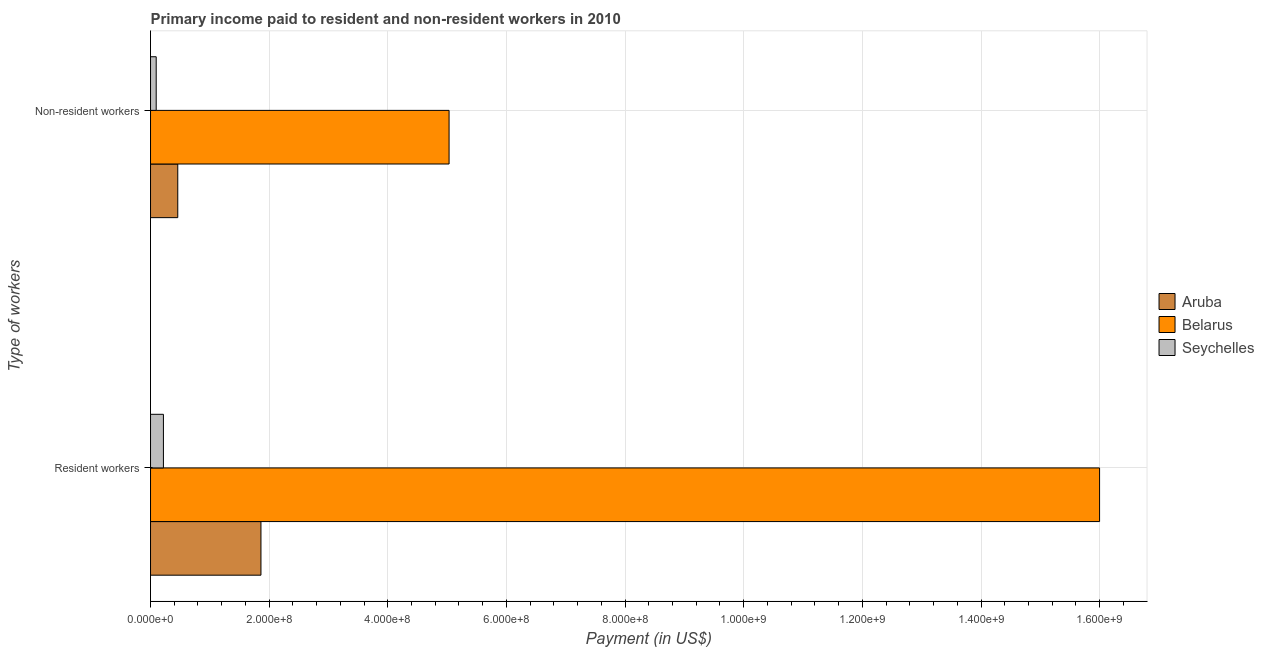How many different coloured bars are there?
Offer a very short reply. 3. How many bars are there on the 2nd tick from the top?
Make the answer very short. 3. How many bars are there on the 2nd tick from the bottom?
Provide a short and direct response. 3. What is the label of the 1st group of bars from the top?
Provide a succinct answer. Non-resident workers. What is the payment made to non-resident workers in Aruba?
Your answer should be very brief. 4.59e+07. Across all countries, what is the maximum payment made to resident workers?
Your response must be concise. 1.60e+09. Across all countries, what is the minimum payment made to resident workers?
Make the answer very short. 2.17e+07. In which country was the payment made to resident workers maximum?
Provide a short and direct response. Belarus. In which country was the payment made to resident workers minimum?
Give a very brief answer. Seychelles. What is the total payment made to non-resident workers in the graph?
Make the answer very short. 5.59e+08. What is the difference between the payment made to resident workers in Aruba and that in Seychelles?
Give a very brief answer. 1.64e+08. What is the difference between the payment made to non-resident workers in Seychelles and the payment made to resident workers in Aruba?
Give a very brief answer. -1.77e+08. What is the average payment made to resident workers per country?
Your answer should be compact. 6.03e+08. What is the difference between the payment made to non-resident workers and payment made to resident workers in Belarus?
Your answer should be compact. -1.10e+09. What is the ratio of the payment made to resident workers in Seychelles to that in Belarus?
Your answer should be compact. 0.01. In how many countries, is the payment made to resident workers greater than the average payment made to resident workers taken over all countries?
Ensure brevity in your answer.  1. What does the 2nd bar from the top in Non-resident workers represents?
Provide a short and direct response. Belarus. What does the 2nd bar from the bottom in Non-resident workers represents?
Provide a succinct answer. Belarus. How many bars are there?
Ensure brevity in your answer.  6. How many countries are there in the graph?
Offer a very short reply. 3. What is the difference between two consecutive major ticks on the X-axis?
Your answer should be compact. 2.00e+08. Are the values on the major ticks of X-axis written in scientific E-notation?
Keep it short and to the point. Yes. Does the graph contain grids?
Keep it short and to the point. Yes. Where does the legend appear in the graph?
Keep it short and to the point. Center right. How many legend labels are there?
Provide a short and direct response. 3. What is the title of the graph?
Provide a succinct answer. Primary income paid to resident and non-resident workers in 2010. What is the label or title of the X-axis?
Ensure brevity in your answer.  Payment (in US$). What is the label or title of the Y-axis?
Offer a terse response. Type of workers. What is the Payment (in US$) of Aruba in Resident workers?
Give a very brief answer. 1.86e+08. What is the Payment (in US$) of Belarus in Resident workers?
Offer a very short reply. 1.60e+09. What is the Payment (in US$) in Seychelles in Resident workers?
Your answer should be compact. 2.17e+07. What is the Payment (in US$) in Aruba in Non-resident workers?
Your answer should be very brief. 4.59e+07. What is the Payment (in US$) of Belarus in Non-resident workers?
Provide a short and direct response. 5.03e+08. What is the Payment (in US$) of Seychelles in Non-resident workers?
Provide a short and direct response. 9.57e+06. Across all Type of workers, what is the maximum Payment (in US$) in Aruba?
Provide a succinct answer. 1.86e+08. Across all Type of workers, what is the maximum Payment (in US$) in Belarus?
Keep it short and to the point. 1.60e+09. Across all Type of workers, what is the maximum Payment (in US$) of Seychelles?
Provide a short and direct response. 2.17e+07. Across all Type of workers, what is the minimum Payment (in US$) of Aruba?
Your answer should be compact. 4.59e+07. Across all Type of workers, what is the minimum Payment (in US$) in Belarus?
Your response must be concise. 5.03e+08. Across all Type of workers, what is the minimum Payment (in US$) in Seychelles?
Offer a terse response. 9.57e+06. What is the total Payment (in US$) in Aruba in the graph?
Make the answer very short. 2.32e+08. What is the total Payment (in US$) in Belarus in the graph?
Provide a short and direct response. 2.10e+09. What is the total Payment (in US$) of Seychelles in the graph?
Keep it short and to the point. 3.13e+07. What is the difference between the Payment (in US$) in Aruba in Resident workers and that in Non-resident workers?
Ensure brevity in your answer.  1.40e+08. What is the difference between the Payment (in US$) in Belarus in Resident workers and that in Non-resident workers?
Offer a terse response. 1.10e+09. What is the difference between the Payment (in US$) of Seychelles in Resident workers and that in Non-resident workers?
Offer a terse response. 1.22e+07. What is the difference between the Payment (in US$) in Aruba in Resident workers and the Payment (in US$) in Belarus in Non-resident workers?
Make the answer very short. -3.17e+08. What is the difference between the Payment (in US$) in Aruba in Resident workers and the Payment (in US$) in Seychelles in Non-resident workers?
Your answer should be compact. 1.77e+08. What is the difference between the Payment (in US$) in Belarus in Resident workers and the Payment (in US$) in Seychelles in Non-resident workers?
Provide a succinct answer. 1.59e+09. What is the average Payment (in US$) of Aruba per Type of workers?
Make the answer very short. 1.16e+08. What is the average Payment (in US$) in Belarus per Type of workers?
Provide a short and direct response. 1.05e+09. What is the average Payment (in US$) in Seychelles per Type of workers?
Keep it short and to the point. 1.57e+07. What is the difference between the Payment (in US$) of Aruba and Payment (in US$) of Belarus in Resident workers?
Provide a succinct answer. -1.41e+09. What is the difference between the Payment (in US$) of Aruba and Payment (in US$) of Seychelles in Resident workers?
Provide a short and direct response. 1.64e+08. What is the difference between the Payment (in US$) of Belarus and Payment (in US$) of Seychelles in Resident workers?
Ensure brevity in your answer.  1.58e+09. What is the difference between the Payment (in US$) of Aruba and Payment (in US$) of Belarus in Non-resident workers?
Keep it short and to the point. -4.57e+08. What is the difference between the Payment (in US$) of Aruba and Payment (in US$) of Seychelles in Non-resident workers?
Provide a succinct answer. 3.63e+07. What is the difference between the Payment (in US$) in Belarus and Payment (in US$) in Seychelles in Non-resident workers?
Ensure brevity in your answer.  4.94e+08. What is the ratio of the Payment (in US$) of Aruba in Resident workers to that in Non-resident workers?
Ensure brevity in your answer.  4.05. What is the ratio of the Payment (in US$) of Belarus in Resident workers to that in Non-resident workers?
Provide a short and direct response. 3.18. What is the ratio of the Payment (in US$) in Seychelles in Resident workers to that in Non-resident workers?
Keep it short and to the point. 2.27. What is the difference between the highest and the second highest Payment (in US$) in Aruba?
Offer a very short reply. 1.40e+08. What is the difference between the highest and the second highest Payment (in US$) of Belarus?
Your answer should be compact. 1.10e+09. What is the difference between the highest and the second highest Payment (in US$) in Seychelles?
Your answer should be very brief. 1.22e+07. What is the difference between the highest and the lowest Payment (in US$) in Aruba?
Ensure brevity in your answer.  1.40e+08. What is the difference between the highest and the lowest Payment (in US$) in Belarus?
Ensure brevity in your answer.  1.10e+09. What is the difference between the highest and the lowest Payment (in US$) of Seychelles?
Keep it short and to the point. 1.22e+07. 